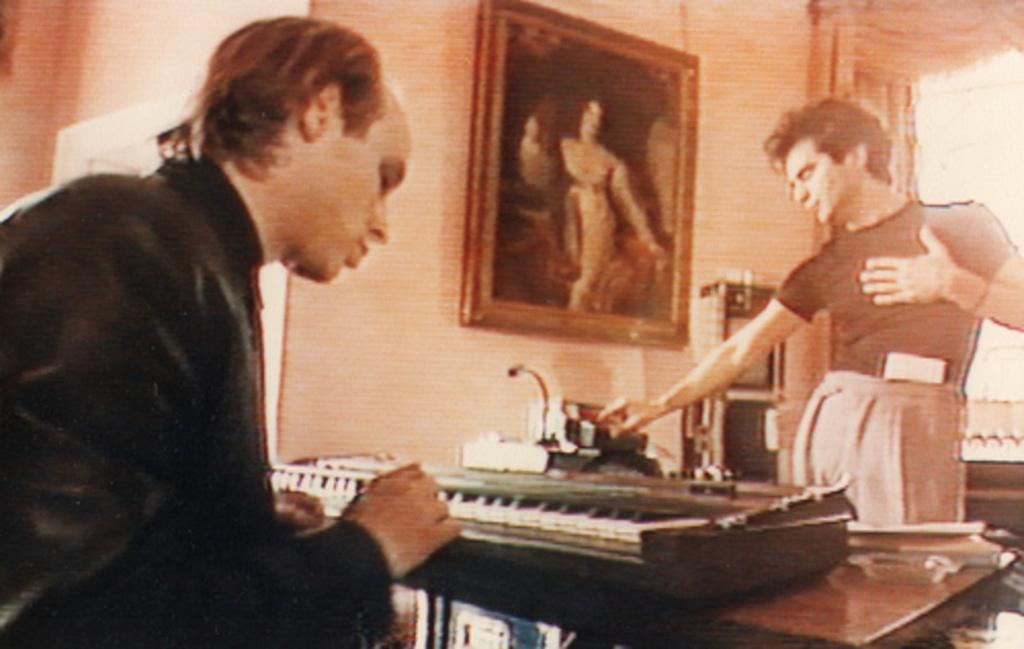Where is the person sitting in the image? The person is sitting in the left corner of the image. What is the person sitting in front of? The person is sitting in front of a piano. Can you describe the position of the second person in the image? There is another person standing in front of the person sitting at the piano. Is the person sitting at the piano wearing a veil in the image? There is no mention of a veil in the image, so we cannot determine if the person is wearing one. 